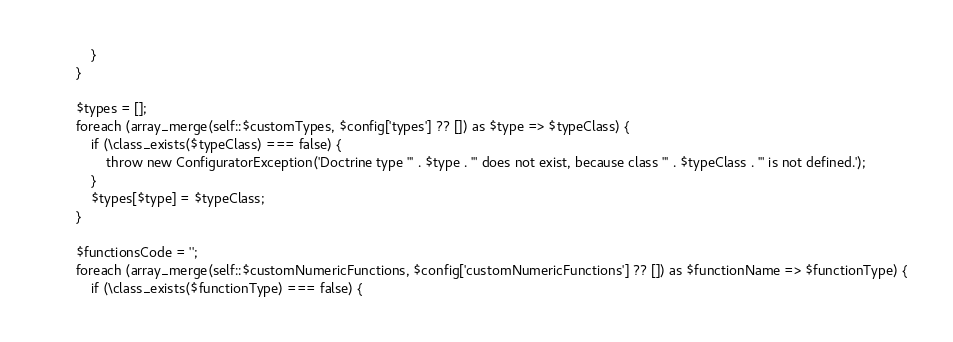<code> <loc_0><loc_0><loc_500><loc_500><_PHP_>			}
		}

		$types = [];
		foreach (array_merge(self::$customTypes, $config['types'] ?? []) as $type => $typeClass) {
			if (\class_exists($typeClass) === false) {
				throw new ConfiguratorException('Doctrine type "' . $type . '" does not exist, because class "' . $typeClass . '" is not defined.');
			}
			$types[$type] = $typeClass;
		}

		$functionsCode = '';
		foreach (array_merge(self::$customNumericFunctions, $config['customNumericFunctions'] ?? []) as $functionName => $functionType) {
			if (\class_exists($functionType) === false) {</code> 